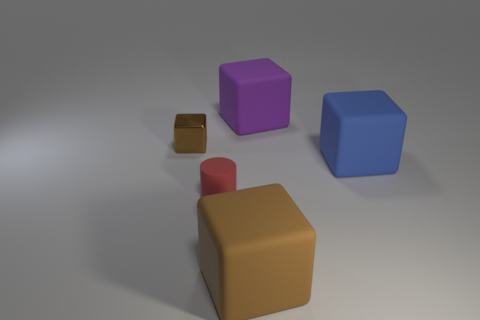Add 1 small balls. How many objects exist? 6 Subtract all cylinders. How many objects are left? 4 Add 2 large brown shiny spheres. How many large brown shiny spheres exist? 2 Subtract 0 cyan spheres. How many objects are left? 5 Subtract all big brown cubes. Subtract all big blue cylinders. How many objects are left? 4 Add 3 small cubes. How many small cubes are left? 4 